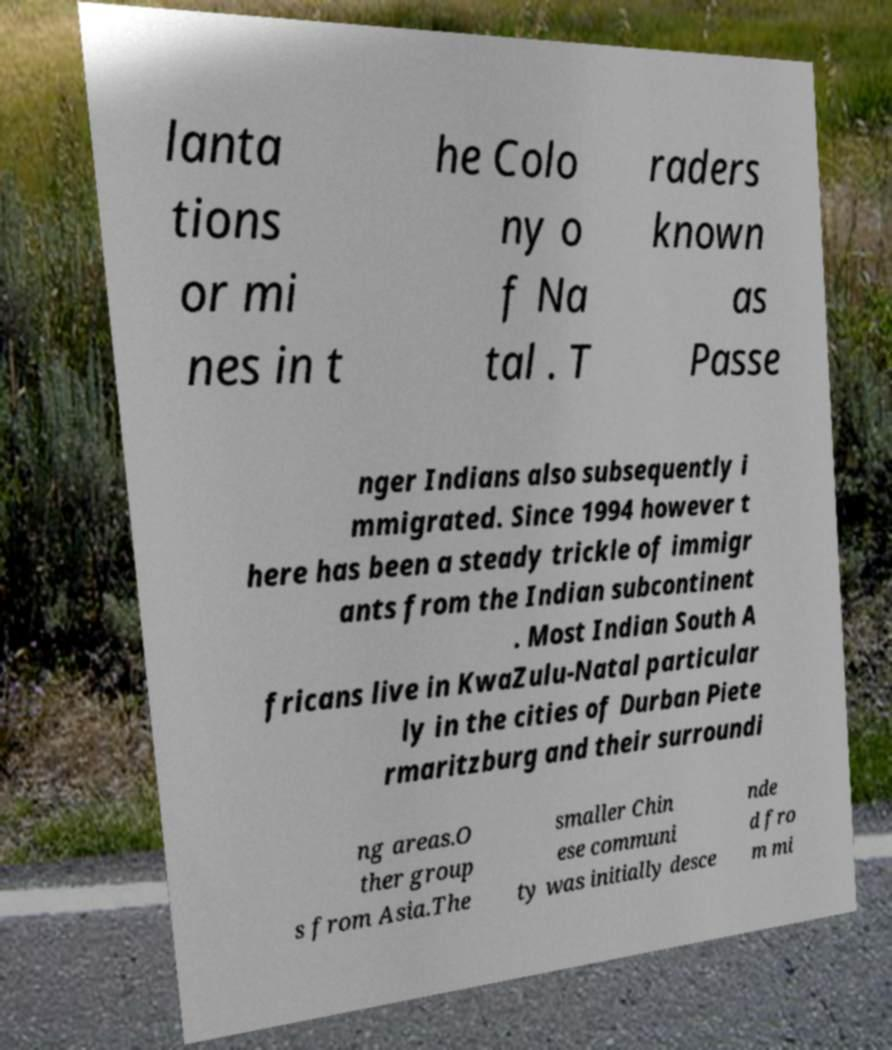Please read and relay the text visible in this image. What does it say? lanta tions or mi nes in t he Colo ny o f Na tal . T raders known as Passe nger Indians also subsequently i mmigrated. Since 1994 however t here has been a steady trickle of immigr ants from the Indian subcontinent . Most Indian South A fricans live in KwaZulu-Natal particular ly in the cities of Durban Piete rmaritzburg and their surroundi ng areas.O ther group s from Asia.The smaller Chin ese communi ty was initially desce nde d fro m mi 